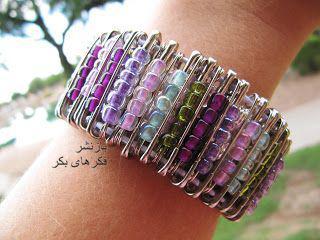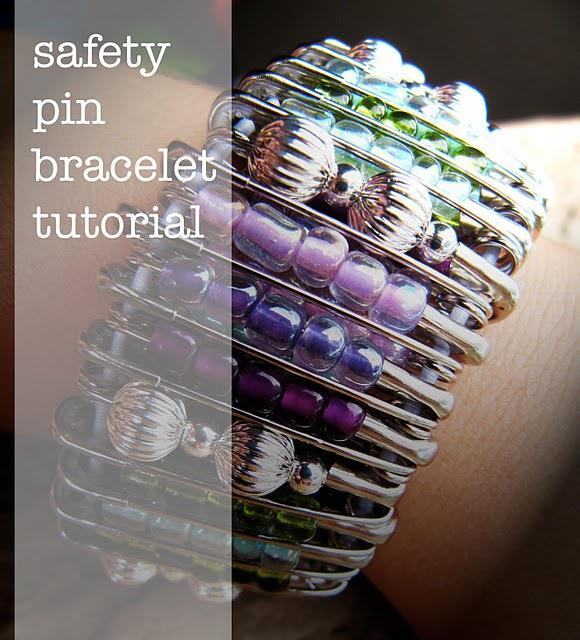The first image is the image on the left, the second image is the image on the right. Considering the images on both sides, is "A bracelet made of pins is worn on a wrist in the image on the left." valid? Answer yes or no. Yes. The first image is the image on the left, the second image is the image on the right. For the images shown, is this caption "An image shows only one decorative pin with a pattern created by dangling pins strung with beads." true? Answer yes or no. No. 